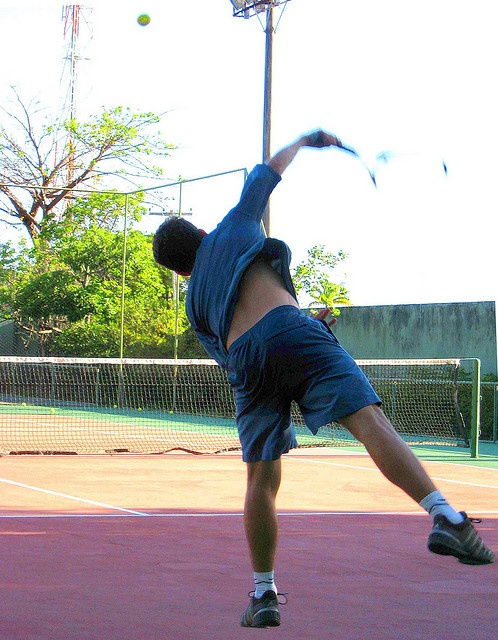Describe the objects in this image and their specific colors. I can see people in white, black, navy, gray, and blue tones, tennis racket in white and lightblue tones, sports ball in white, olive, turquoise, and darkgray tones, sports ball in white, khaki, lightyellow, and yellow tones, and sports ball in white, olive, lightgreen, gray, and darkgreen tones in this image. 